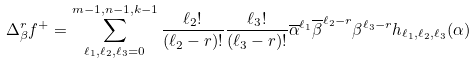Convert formula to latex. <formula><loc_0><loc_0><loc_500><loc_500>\Delta _ { \beta } ^ { r } f ^ { + } & = \sum _ { \ell _ { 1 } , \ell _ { 2 } , \ell _ { 3 } = 0 } ^ { m - 1 , n - 1 , k - 1 } \frac { \ell _ { 2 } ! } { ( \ell _ { 2 } - r ) ! } \frac { \ell _ { 3 } ! } { ( \ell _ { 3 } - r ) ! } \overline { \alpha } ^ { \ell _ { 1 } } \overline { \beta } ^ { \ell _ { 2 } - r } \beta ^ { \ell _ { 3 } - r } h _ { \ell _ { 1 } , \ell _ { 2 } , \ell _ { 3 } } ( \alpha )</formula> 